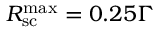Convert formula to latex. <formula><loc_0><loc_0><loc_500><loc_500>R _ { s c } ^ { \max } = 0 . 2 5 \Gamma</formula> 